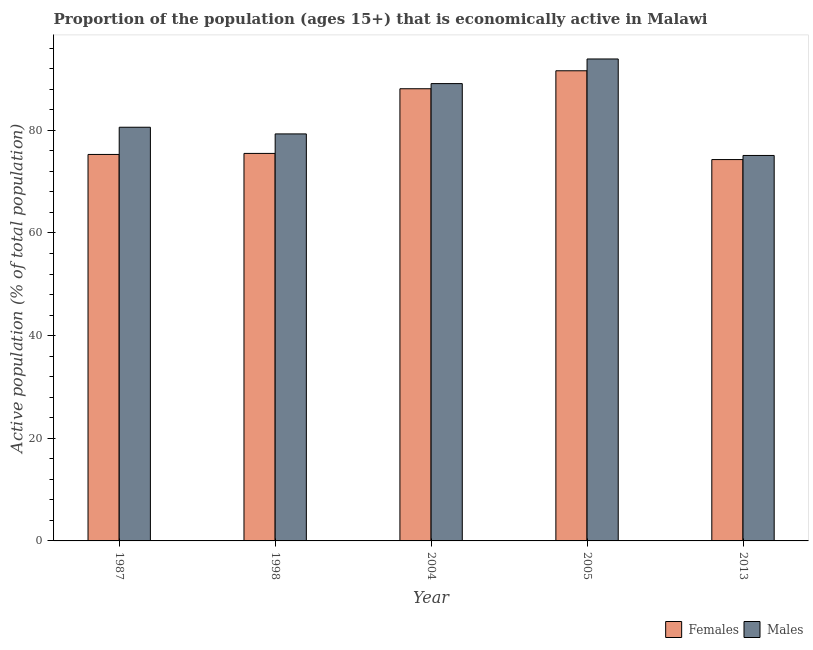How many groups of bars are there?
Your answer should be very brief. 5. Are the number of bars per tick equal to the number of legend labels?
Provide a short and direct response. Yes. How many bars are there on the 4th tick from the right?
Keep it short and to the point. 2. What is the label of the 2nd group of bars from the left?
Ensure brevity in your answer.  1998. What is the percentage of economically active male population in 2013?
Provide a short and direct response. 75.1. Across all years, what is the maximum percentage of economically active male population?
Make the answer very short. 93.9. Across all years, what is the minimum percentage of economically active male population?
Provide a succinct answer. 75.1. In which year was the percentage of economically active female population minimum?
Give a very brief answer. 2013. What is the total percentage of economically active female population in the graph?
Ensure brevity in your answer.  404.8. What is the difference between the percentage of economically active male population in 2005 and that in 2013?
Keep it short and to the point. 18.8. What is the difference between the percentage of economically active male population in 2005 and the percentage of economically active female population in 2004?
Your answer should be very brief. 4.8. What is the average percentage of economically active male population per year?
Your response must be concise. 83.6. What is the ratio of the percentage of economically active female population in 1998 to that in 2004?
Your answer should be very brief. 0.86. Is the percentage of economically active male population in 1998 less than that in 2004?
Provide a succinct answer. Yes. Is the difference between the percentage of economically active female population in 2004 and 2013 greater than the difference between the percentage of economically active male population in 2004 and 2013?
Make the answer very short. No. What is the difference between the highest and the second highest percentage of economically active male population?
Ensure brevity in your answer.  4.8. What is the difference between the highest and the lowest percentage of economically active male population?
Your answer should be compact. 18.8. In how many years, is the percentage of economically active male population greater than the average percentage of economically active male population taken over all years?
Give a very brief answer. 2. What does the 2nd bar from the left in 2005 represents?
Provide a short and direct response. Males. What does the 1st bar from the right in 1987 represents?
Your answer should be compact. Males. How many bars are there?
Give a very brief answer. 10. How many years are there in the graph?
Give a very brief answer. 5. What is the difference between two consecutive major ticks on the Y-axis?
Keep it short and to the point. 20. Does the graph contain any zero values?
Keep it short and to the point. No. Does the graph contain grids?
Your response must be concise. No. Where does the legend appear in the graph?
Ensure brevity in your answer.  Bottom right. How many legend labels are there?
Keep it short and to the point. 2. What is the title of the graph?
Offer a very short reply. Proportion of the population (ages 15+) that is economically active in Malawi. Does "Domestic Liabilities" appear as one of the legend labels in the graph?
Provide a short and direct response. No. What is the label or title of the Y-axis?
Ensure brevity in your answer.  Active population (% of total population). What is the Active population (% of total population) of Females in 1987?
Your answer should be compact. 75.3. What is the Active population (% of total population) of Males in 1987?
Provide a succinct answer. 80.6. What is the Active population (% of total population) in Females in 1998?
Give a very brief answer. 75.5. What is the Active population (% of total population) of Males in 1998?
Keep it short and to the point. 79.3. What is the Active population (% of total population) in Females in 2004?
Your response must be concise. 88.1. What is the Active population (% of total population) of Males in 2004?
Provide a succinct answer. 89.1. What is the Active population (% of total population) in Females in 2005?
Provide a short and direct response. 91.6. What is the Active population (% of total population) in Males in 2005?
Keep it short and to the point. 93.9. What is the Active population (% of total population) in Females in 2013?
Offer a terse response. 74.3. What is the Active population (% of total population) in Males in 2013?
Provide a succinct answer. 75.1. Across all years, what is the maximum Active population (% of total population) in Females?
Provide a succinct answer. 91.6. Across all years, what is the maximum Active population (% of total population) of Males?
Make the answer very short. 93.9. Across all years, what is the minimum Active population (% of total population) of Females?
Keep it short and to the point. 74.3. Across all years, what is the minimum Active population (% of total population) of Males?
Provide a short and direct response. 75.1. What is the total Active population (% of total population) of Females in the graph?
Make the answer very short. 404.8. What is the total Active population (% of total population) of Males in the graph?
Provide a succinct answer. 418. What is the difference between the Active population (% of total population) of Males in 1987 and that in 1998?
Provide a short and direct response. 1.3. What is the difference between the Active population (% of total population) of Females in 1987 and that in 2004?
Keep it short and to the point. -12.8. What is the difference between the Active population (% of total population) in Males in 1987 and that in 2004?
Provide a short and direct response. -8.5. What is the difference between the Active population (% of total population) of Females in 1987 and that in 2005?
Offer a very short reply. -16.3. What is the difference between the Active population (% of total population) of Males in 1987 and that in 2005?
Make the answer very short. -13.3. What is the difference between the Active population (% of total population) of Females in 1987 and that in 2013?
Give a very brief answer. 1. What is the difference between the Active population (% of total population) of Females in 1998 and that in 2004?
Make the answer very short. -12.6. What is the difference between the Active population (% of total population) in Females in 1998 and that in 2005?
Offer a terse response. -16.1. What is the difference between the Active population (% of total population) in Males in 1998 and that in 2005?
Give a very brief answer. -14.6. What is the difference between the Active population (% of total population) of Females in 1998 and that in 2013?
Your response must be concise. 1.2. What is the difference between the Active population (% of total population) of Males in 1998 and that in 2013?
Provide a succinct answer. 4.2. What is the difference between the Active population (% of total population) of Females in 2004 and that in 2005?
Make the answer very short. -3.5. What is the difference between the Active population (% of total population) in Males in 2004 and that in 2005?
Offer a very short reply. -4.8. What is the difference between the Active population (% of total population) in Females in 2004 and that in 2013?
Make the answer very short. 13.8. What is the difference between the Active population (% of total population) in Females in 2005 and that in 2013?
Ensure brevity in your answer.  17.3. What is the difference between the Active population (% of total population) of Males in 2005 and that in 2013?
Make the answer very short. 18.8. What is the difference between the Active population (% of total population) of Females in 1987 and the Active population (% of total population) of Males in 2004?
Your response must be concise. -13.8. What is the difference between the Active population (% of total population) of Females in 1987 and the Active population (% of total population) of Males in 2005?
Ensure brevity in your answer.  -18.6. What is the difference between the Active population (% of total population) of Females in 1998 and the Active population (% of total population) of Males in 2005?
Offer a very short reply. -18.4. What is the difference between the Active population (% of total population) of Females in 2004 and the Active population (% of total population) of Males in 2005?
Make the answer very short. -5.8. What is the difference between the Active population (% of total population) of Females in 2005 and the Active population (% of total population) of Males in 2013?
Offer a terse response. 16.5. What is the average Active population (% of total population) of Females per year?
Offer a very short reply. 80.96. What is the average Active population (% of total population) of Males per year?
Keep it short and to the point. 83.6. In the year 1987, what is the difference between the Active population (% of total population) of Females and Active population (% of total population) of Males?
Give a very brief answer. -5.3. In the year 2004, what is the difference between the Active population (% of total population) in Females and Active population (% of total population) in Males?
Offer a terse response. -1. In the year 2013, what is the difference between the Active population (% of total population) in Females and Active population (% of total population) in Males?
Provide a short and direct response. -0.8. What is the ratio of the Active population (% of total population) of Males in 1987 to that in 1998?
Ensure brevity in your answer.  1.02. What is the ratio of the Active population (% of total population) of Females in 1987 to that in 2004?
Keep it short and to the point. 0.85. What is the ratio of the Active population (% of total population) in Males in 1987 to that in 2004?
Give a very brief answer. 0.9. What is the ratio of the Active population (% of total population) of Females in 1987 to that in 2005?
Provide a succinct answer. 0.82. What is the ratio of the Active population (% of total population) in Males in 1987 to that in 2005?
Give a very brief answer. 0.86. What is the ratio of the Active population (% of total population) in Females in 1987 to that in 2013?
Your answer should be very brief. 1.01. What is the ratio of the Active population (% of total population) of Males in 1987 to that in 2013?
Your answer should be compact. 1.07. What is the ratio of the Active population (% of total population) of Females in 1998 to that in 2004?
Your answer should be very brief. 0.86. What is the ratio of the Active population (% of total population) of Males in 1998 to that in 2004?
Keep it short and to the point. 0.89. What is the ratio of the Active population (% of total population) of Females in 1998 to that in 2005?
Provide a short and direct response. 0.82. What is the ratio of the Active population (% of total population) of Males in 1998 to that in 2005?
Make the answer very short. 0.84. What is the ratio of the Active population (% of total population) of Females in 1998 to that in 2013?
Give a very brief answer. 1.02. What is the ratio of the Active population (% of total population) of Males in 1998 to that in 2013?
Your response must be concise. 1.06. What is the ratio of the Active population (% of total population) of Females in 2004 to that in 2005?
Ensure brevity in your answer.  0.96. What is the ratio of the Active population (% of total population) of Males in 2004 to that in 2005?
Your answer should be very brief. 0.95. What is the ratio of the Active population (% of total population) of Females in 2004 to that in 2013?
Provide a succinct answer. 1.19. What is the ratio of the Active population (% of total population) of Males in 2004 to that in 2013?
Give a very brief answer. 1.19. What is the ratio of the Active population (% of total population) in Females in 2005 to that in 2013?
Your answer should be very brief. 1.23. What is the ratio of the Active population (% of total population) of Males in 2005 to that in 2013?
Keep it short and to the point. 1.25. What is the difference between the highest and the second highest Active population (% of total population) of Females?
Keep it short and to the point. 3.5. What is the difference between the highest and the lowest Active population (% of total population) in Females?
Keep it short and to the point. 17.3. What is the difference between the highest and the lowest Active population (% of total population) in Males?
Offer a very short reply. 18.8. 